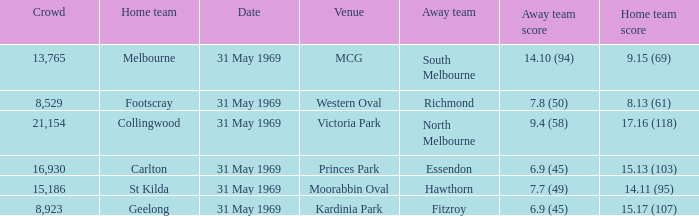11 (95)? St Kilda. 